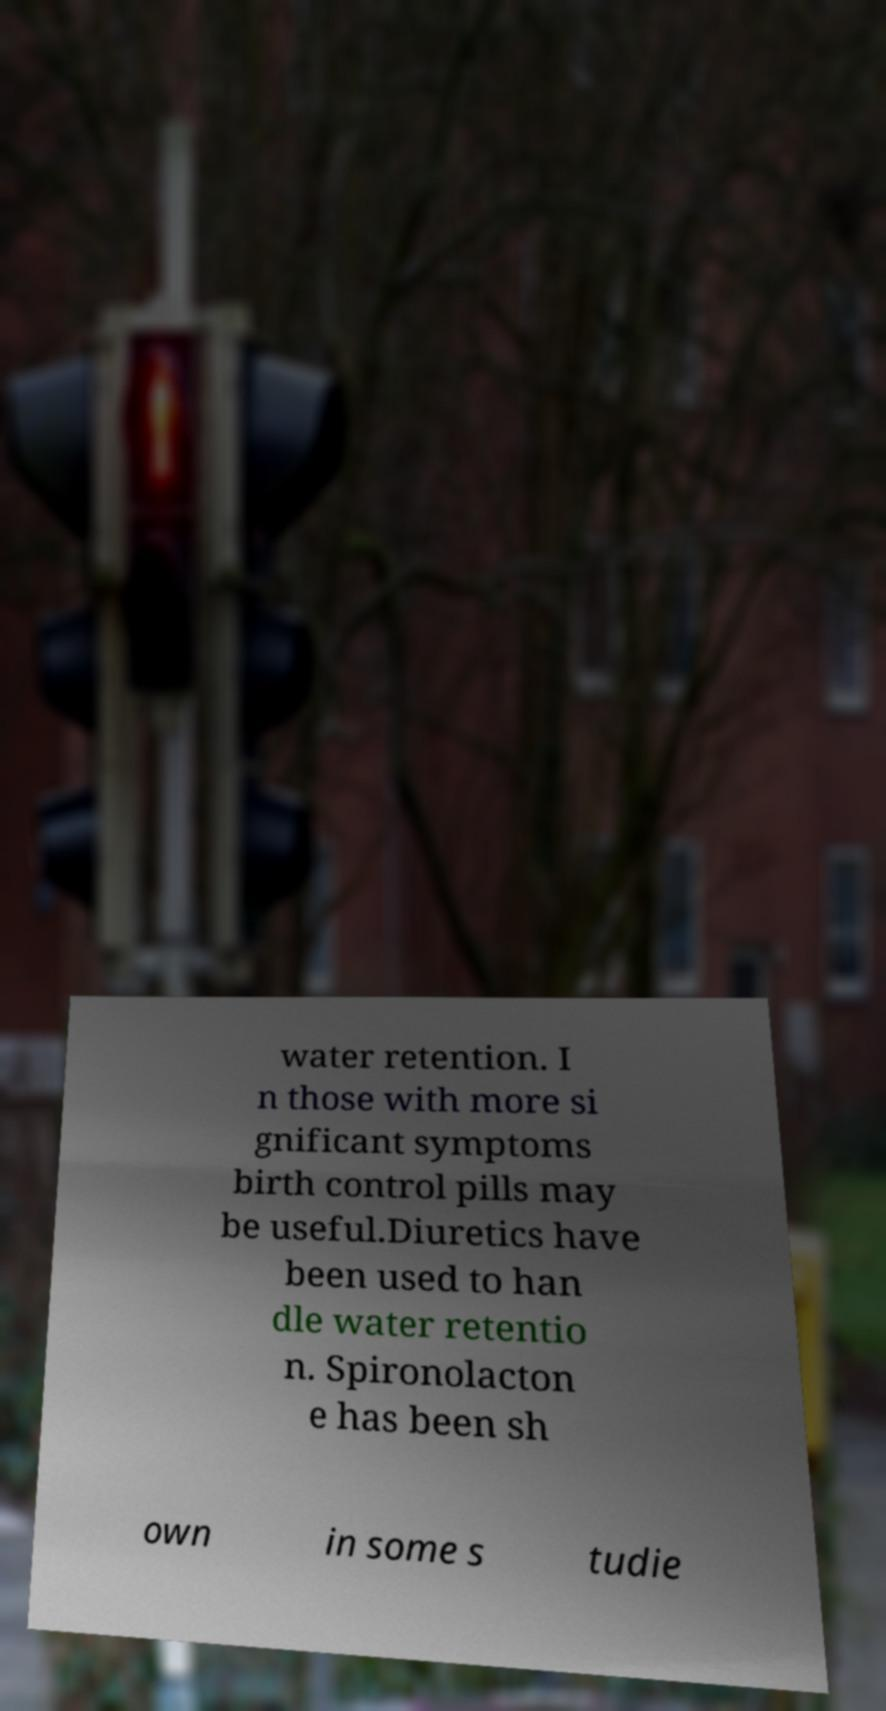There's text embedded in this image that I need extracted. Can you transcribe it verbatim? water retention. I n those with more si gnificant symptoms birth control pills may be useful.Diuretics have been used to han dle water retentio n. Spironolacton e has been sh own in some s tudie 